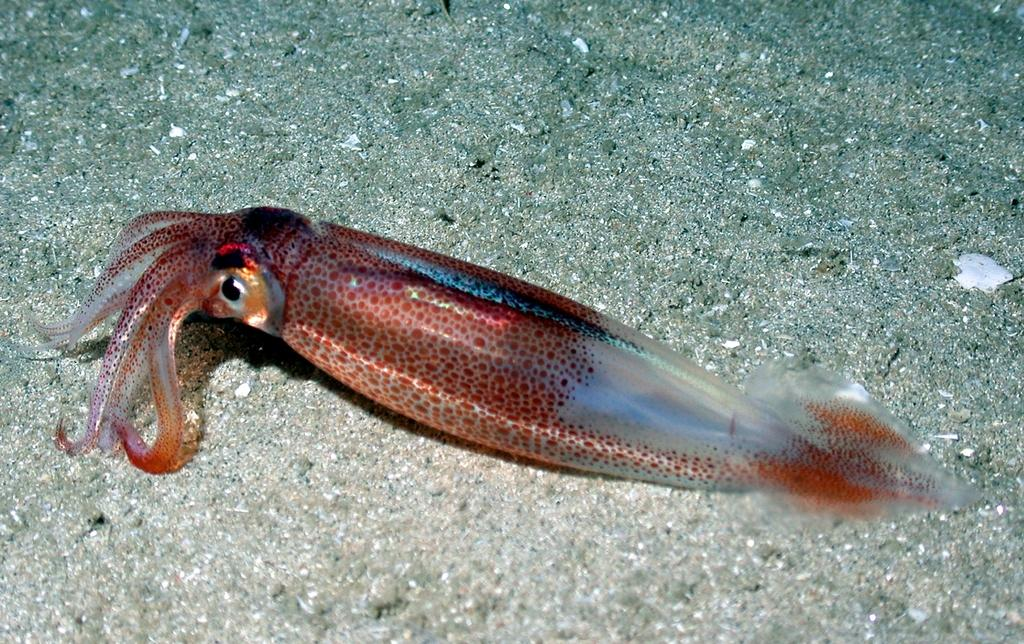What type of animal is present in the image? There is a fish in the image. What type of camera is used to take the picture of the beetle in the image? There is no camera or beetle present in the image; it only features a fish. 